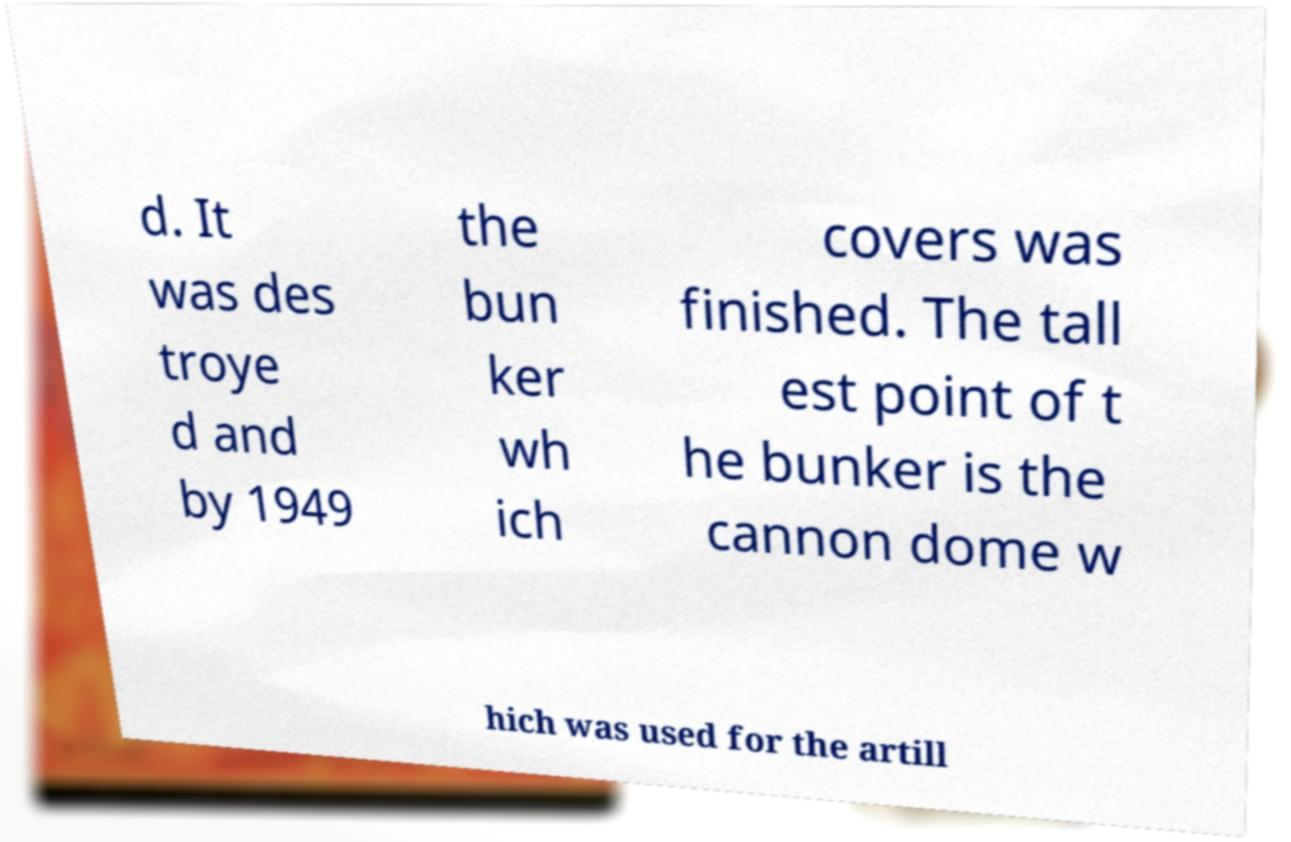Please read and relay the text visible in this image. What does it say? d. It was des troye d and by 1949 the bun ker wh ich covers was finished. The tall est point of t he bunker is the cannon dome w hich was used for the artill 